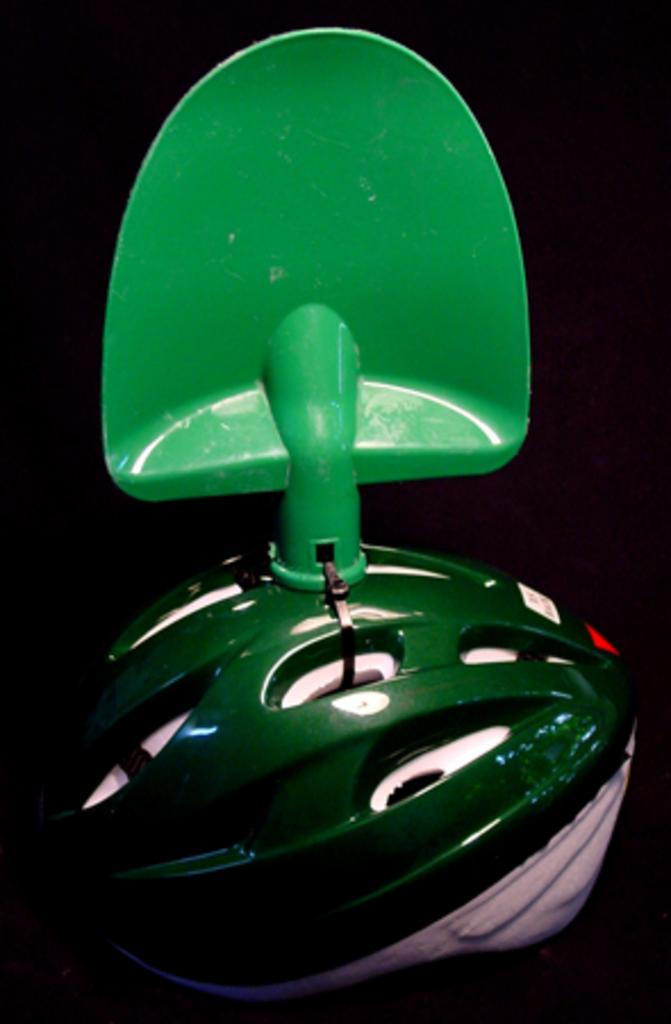What is one of the objects located in the center of the image? There is a helmet in the image. What is the other object located in the center of the image? There is an unspecified object in the image. What time does the self appear in the image? There is no self present in the image, so it is not possible to determine when it might appear. 